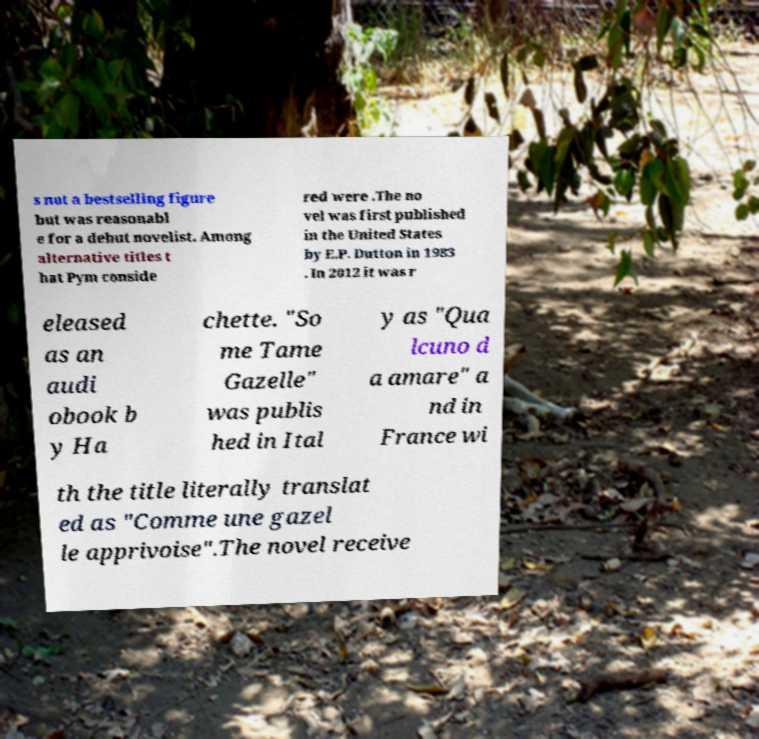Please identify and transcribe the text found in this image. s not a bestselling figure but was reasonabl e for a debut novelist. Among alternative titles t hat Pym conside red were .The no vel was first published in the United States by E.P. Dutton in 1983 . In 2012 it was r eleased as an audi obook b y Ha chette. "So me Tame Gazelle" was publis hed in Ital y as "Qua lcuno d a amare" a nd in France wi th the title literally translat ed as "Comme une gazel le apprivoise".The novel receive 